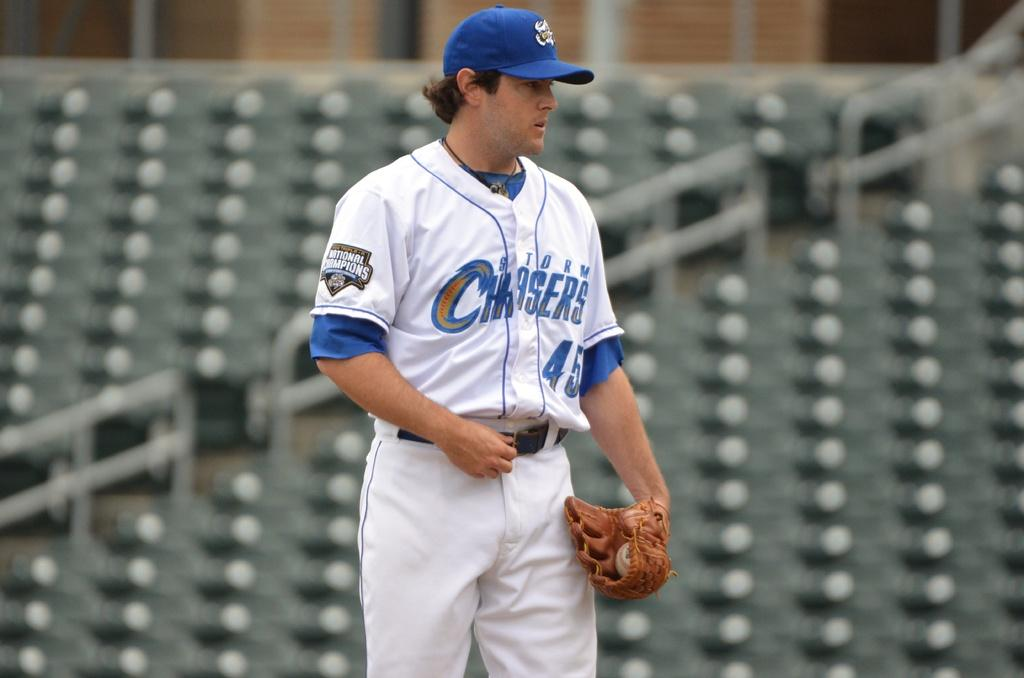<image>
Render a clear and concise summary of the photo. a baseball player from the storm chasers with the ball 